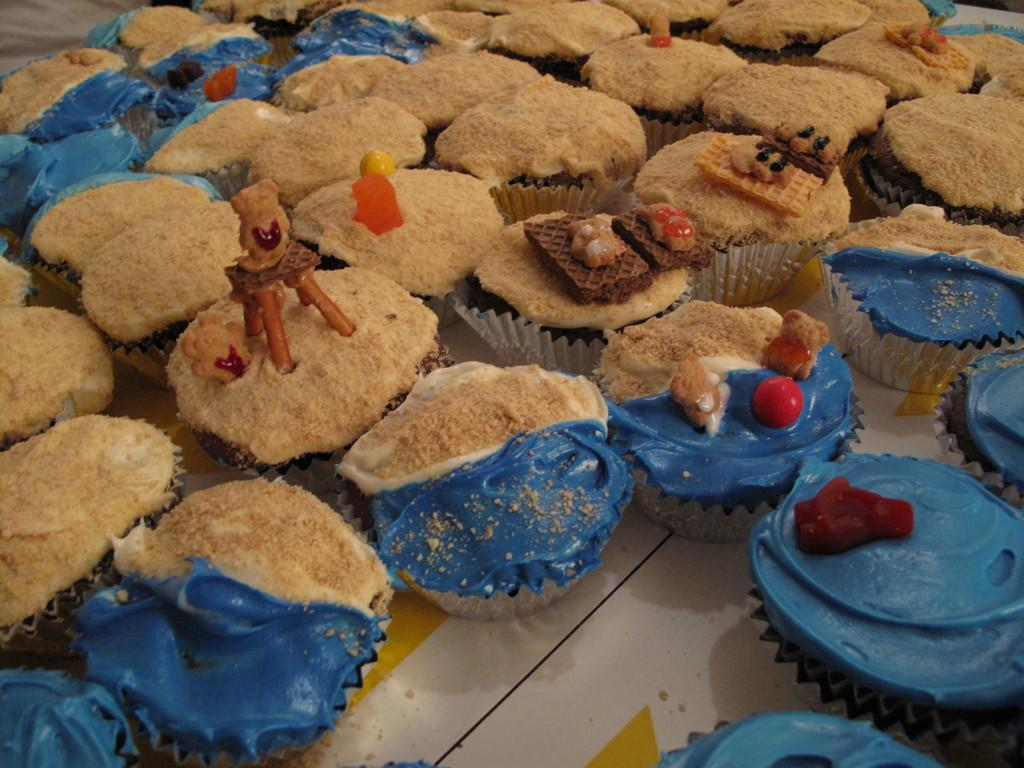What type of food can be seen on the table in the image? There are muffins on the table in the image. What might be used for serving or eating the muffins? The muffins might be served or eaten using plates or napkins, which are not visible in the image. What is the primary location of the muffins in the image? The muffins are on the table in the image. What type of soup is being served in the image? There is no soup present in the image; it features muffins on a table. How does the muffin display its self-awareness in the image? Muffins do not have the ability to display self-awareness, as they are inanimate objects. 